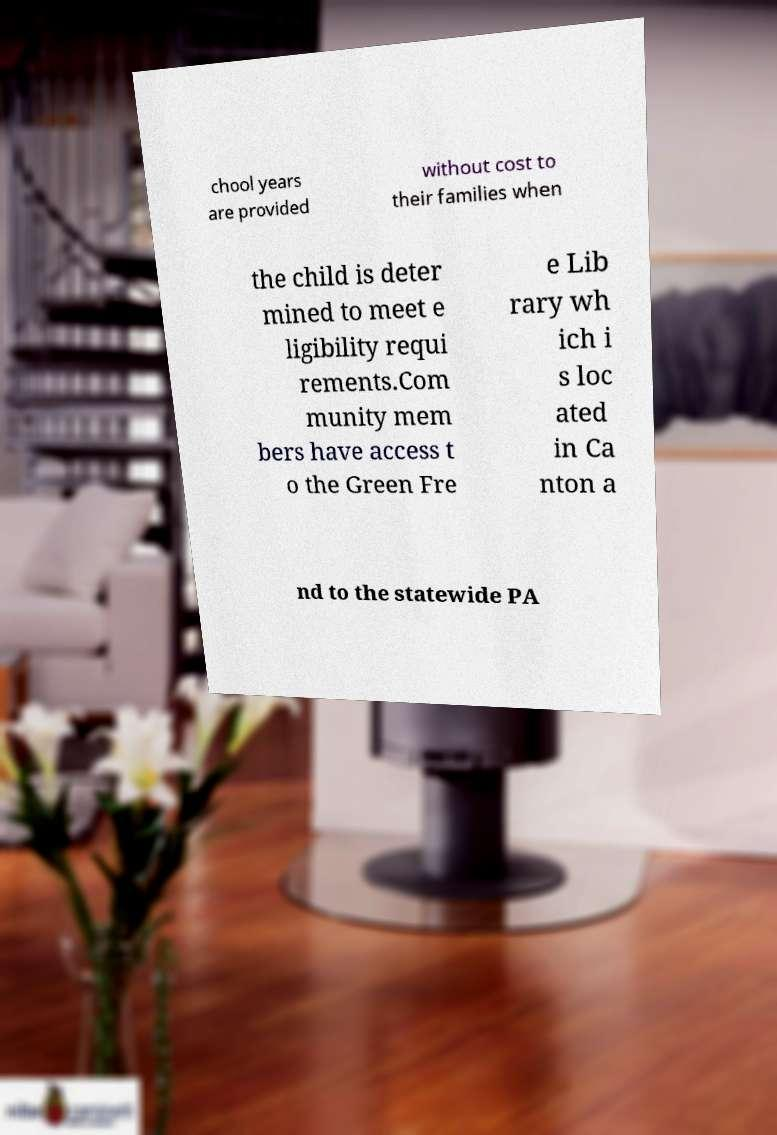For documentation purposes, I need the text within this image transcribed. Could you provide that? chool years are provided without cost to their families when the child is deter mined to meet e ligibility requi rements.Com munity mem bers have access t o the Green Fre e Lib rary wh ich i s loc ated in Ca nton a nd to the statewide PA 